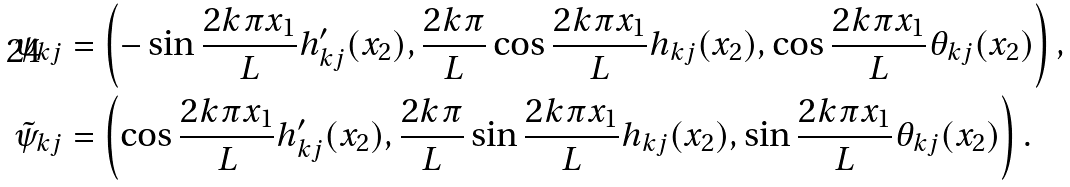<formula> <loc_0><loc_0><loc_500><loc_500>& \psi _ { k j } = \left ( - \sin \frac { 2 k \pi x _ { 1 } } { L } h ^ { \prime } _ { k j } ( x _ { 2 } ) , \frac { 2 k \pi } { L } \cos \frac { 2 k \pi x _ { 1 } } { L } h _ { k j } ( x _ { 2 } ) , \cos \frac { 2 k \pi x _ { 1 } } { L } \theta _ { k j } ( x _ { 2 } ) \right ) , \\ & \tilde { \psi } _ { k j } = \left ( \cos \frac { 2 k \pi x _ { 1 } } { L } h ^ { \prime } _ { k j } ( x _ { 2 } ) , \frac { 2 k \pi } { L } \sin \frac { 2 k \pi x _ { 1 } } { L } h _ { k j } ( x _ { 2 } ) , \sin \frac { 2 k \pi x _ { 1 } } { L } \theta _ { k j } ( x _ { 2 } ) \right ) .</formula> 